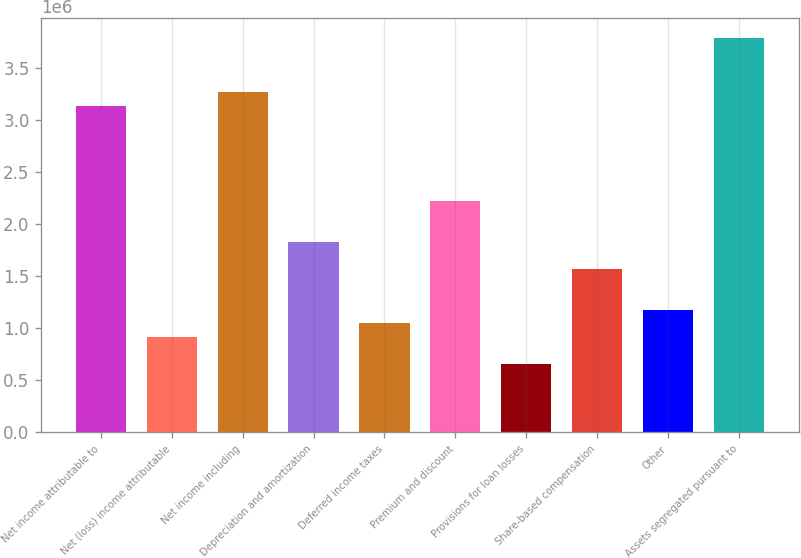<chart> <loc_0><loc_0><loc_500><loc_500><bar_chart><fcel>Net income attributable to<fcel>Net (loss) income attributable<fcel>Net income including<fcel>Depreciation and amortization<fcel>Deferred income taxes<fcel>Premium and discount<fcel>Provisions for loan losses<fcel>Share-based compensation<fcel>Other<fcel>Assets segregated pursuant to<nl><fcel>3.13676e+06<fcel>915645<fcel>3.26742e+06<fcel>1.83022e+06<fcel>1.0463e+06<fcel>2.22218e+06<fcel>654337<fcel>1.56892e+06<fcel>1.17695e+06<fcel>3.79003e+06<nl></chart> 